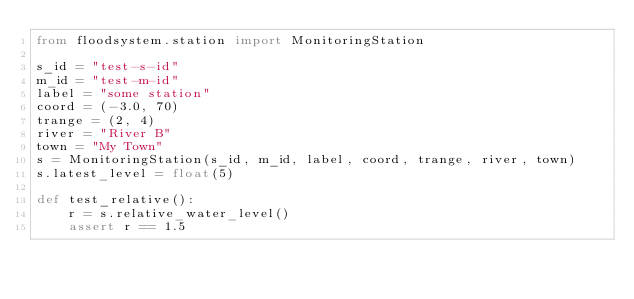<code> <loc_0><loc_0><loc_500><loc_500><_Python_>from floodsystem.station import MonitoringStation

s_id = "test-s-id"
m_id = "test-m-id"
label = "some station"
coord = (-3.0, 70)
trange = (2, 4)
river = "River B"
town = "My Town"
s = MonitoringStation(s_id, m_id, label, coord, trange, river, town)
s.latest_level = float(5)

def test_relative():
    r = s.relative_water_level()
    assert r == 1.5</code> 